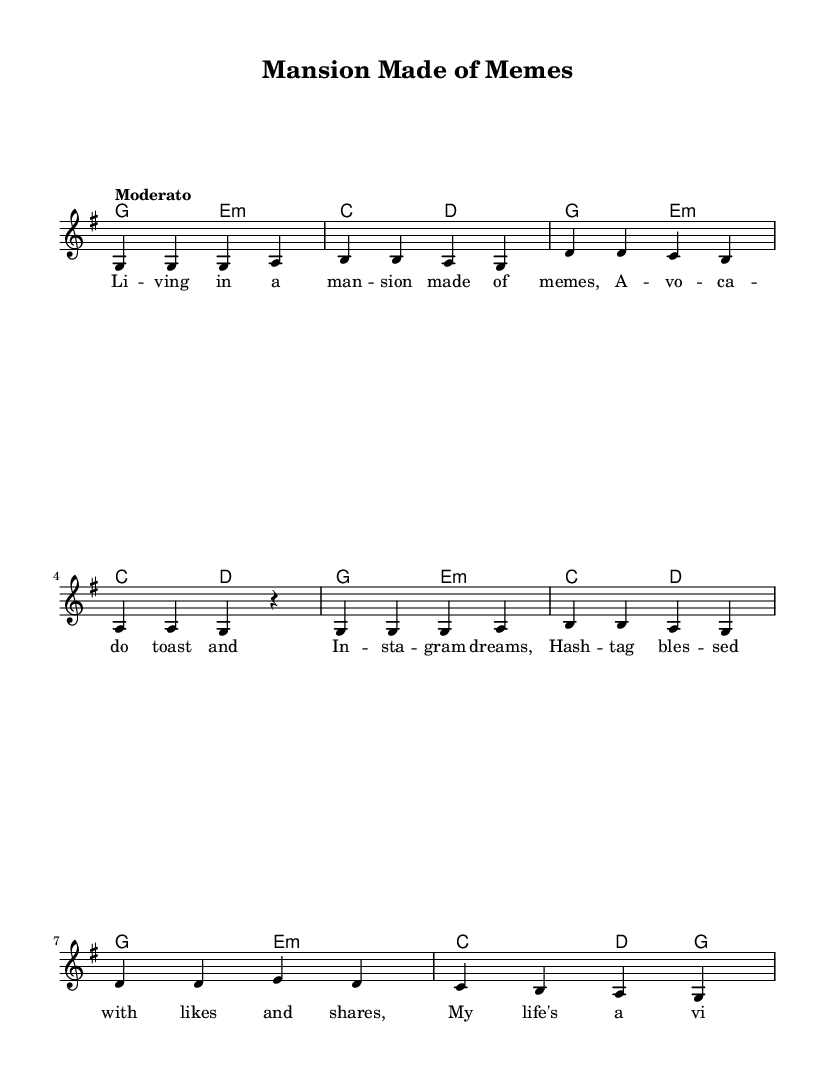What is the key signature of this music? The key signature is G major, which has one sharp (F#). This can be determined by looking at the key indication at the beginning of the score.
Answer: G major What is the time signature of the piece? The time signature is 4/4, which indicates that there are four beats in each measure and the quarter note gets one beat. This is seen at the start of the music.
Answer: 4/4 What is the tempo marking for this piece? The tempo marking is "Moderato," indicating a moderate pace. This is stated in the tempo indication found at the beginning of the score.
Answer: Moderato How many measures are in the piece? The piece has eight measures, which can be confirmed by counting the vertical lines (bar lines) that separate the measures in the score.
Answer: 8 What do the lyrics suggest about the theme of the song? The lyrics poke fun at modern-day lifestyles influenced by social media and pop culture trends. This is evident from phrases like "mansion made of memes" and references to "likes and shares."
Answer: Celebrity lifestyles What is the structure of the music in terms of melody and harmony? The melody consists of a simple repetitive pattern while the harmony alternates between two chords (G major and E minor, then C major and D major). This interaction adds humor to the theme through its simplicity and contrast.
Answer: Melody and harmony interaction 